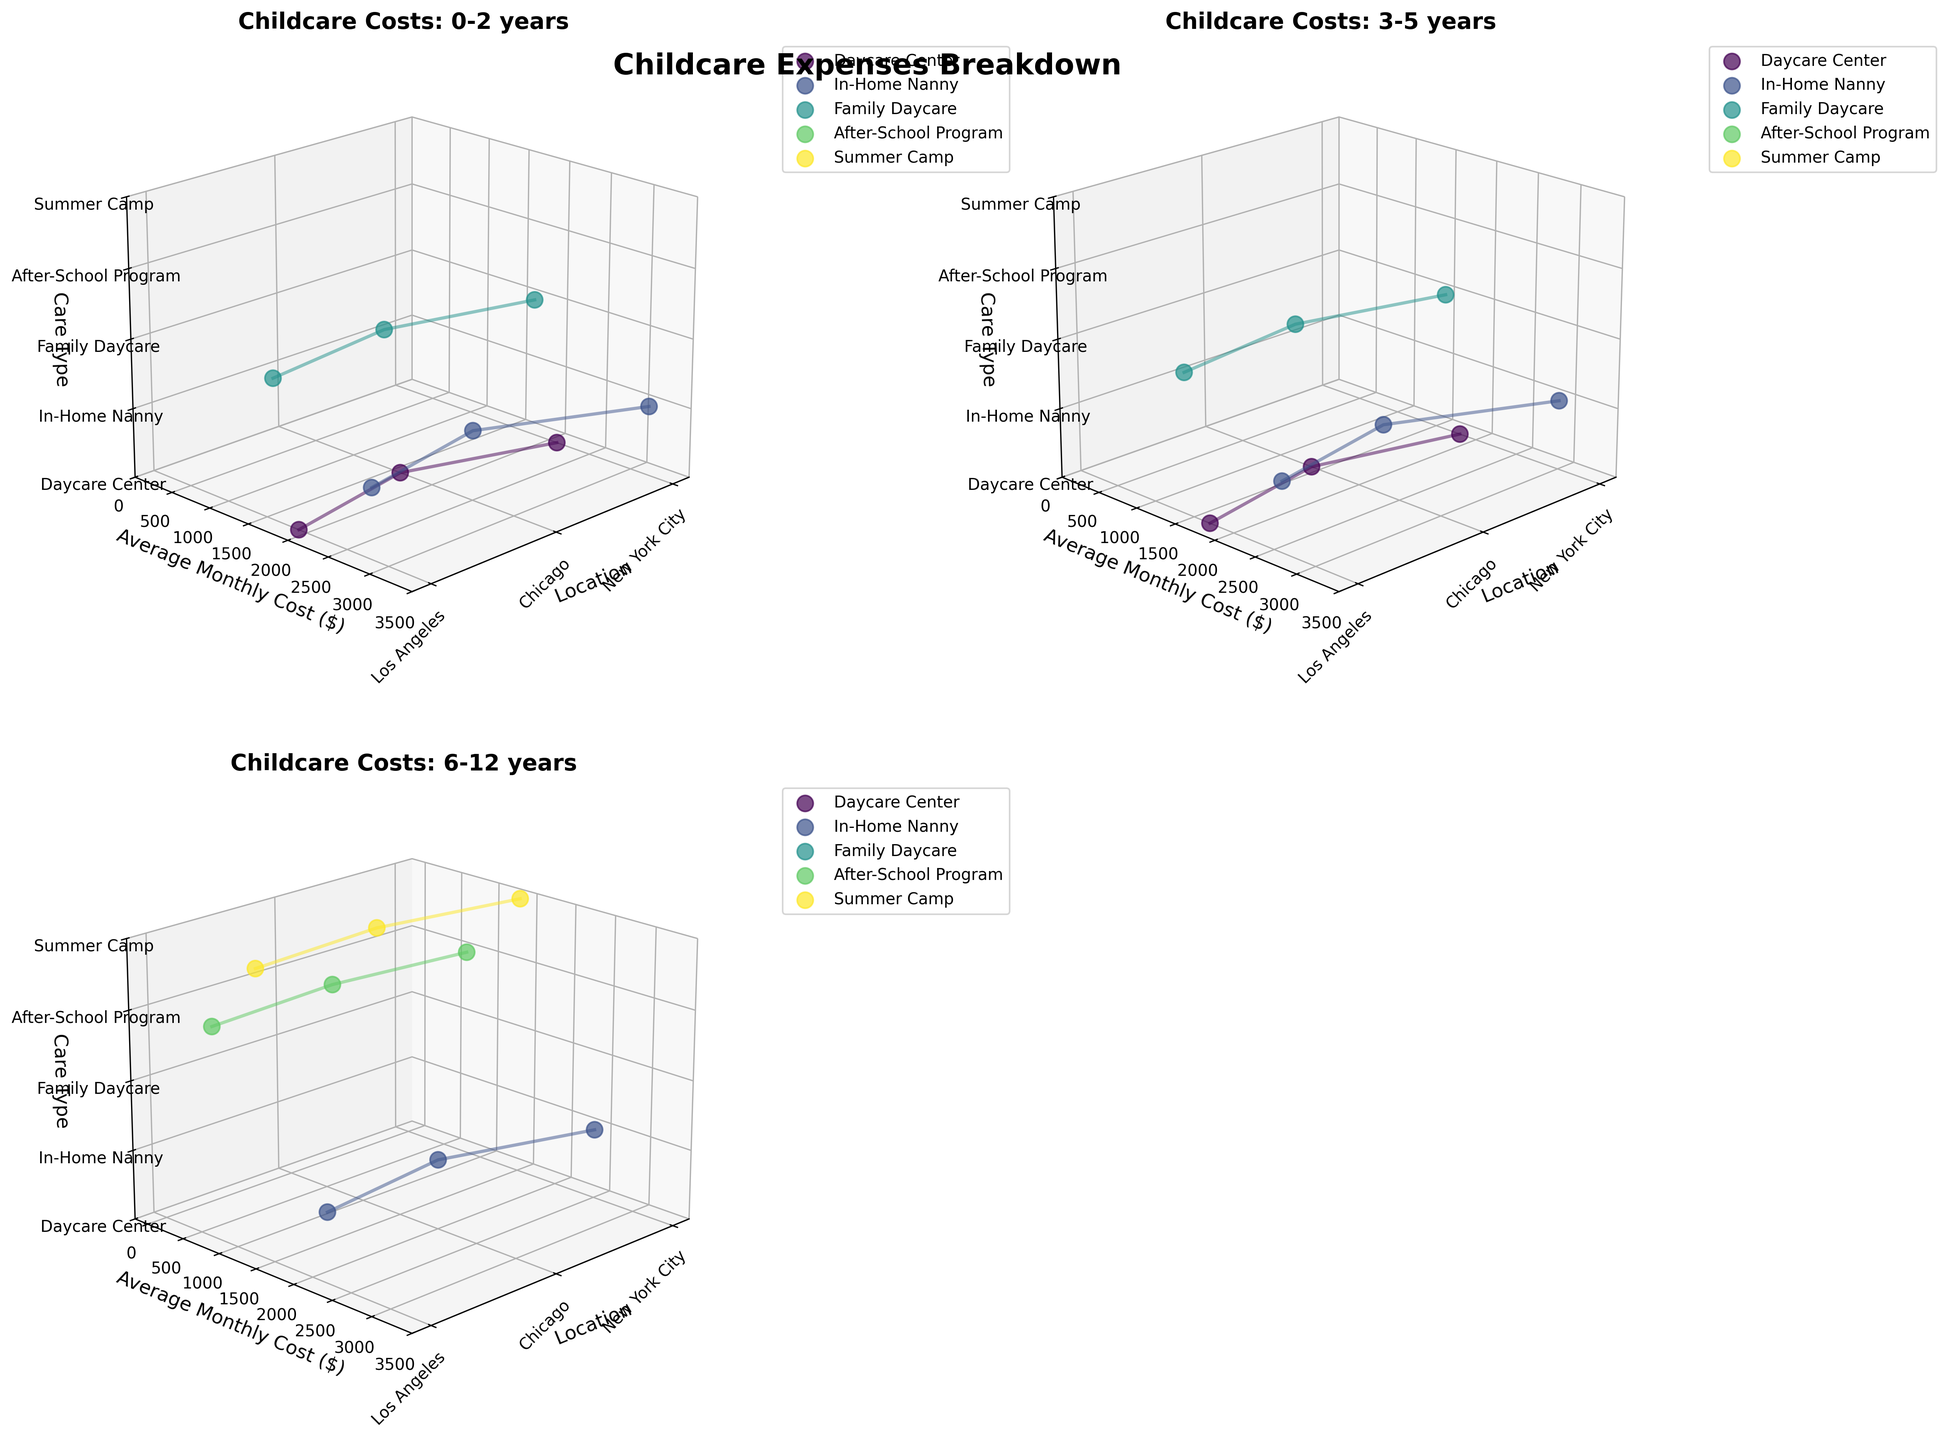What's the title of the figure? The title of the figure is indicated at the top and summarizes the overall content of the plots.
Answer: Childcare Expenses Breakdown Which age group has the plot in the top left corner? The top left plot is for the first age group listed in the subplot titles.
Answer: 0-2 years What is the x-axis label for each subplot? The x-axis label is displayed at the bottom of each subplot and describes the horizontal dimension of the plots.
Answer: Location How many unique childcare types are shown in each subplot? From the distinct colors/markers in the legend for each subplot, you can count the number of different care types displayed.
Answer: 3 for 0-5 years, 3 for 6-12 years Which geographic location has the highest average monthly cost for In-Home Nanny care for children aged 3-5 years? By examining the 3-5 years subplot, find the data points corresponding to In-Home Nanny care and compare their y-values across geographic locations.
Answer: New York City In the 6-12 years group, which care type has the lowest average monthly cost in Chicago? Look at the 6-12 years subplot and compare the y-values of the data points for Chicago across all care types.
Answer: After-School Program What is the average monthly cost for Daycare Center care for the 0-2 years age group in Los Angeles? Refer to the specific data point in the 0-2 years subplot highlighted by the Daycare Center marker in Los Angeles.
Answer: $1900 Is the cost of Family Daycare for 0-2 years old in Chicago higher or lower than in Los Angeles? Compare the y-values of Family Daycare in the 0-2 years subplot for Chicago and Los Angeles.
Answer: Lower Which age group has the highest variation in the average monthly cost for Daycare Center care across all locations? Examine the range of y-values for Daycare Center care across all locations in the corresponding subplots and identify the age group with the widest range.
Answer: 0-2 years What is the range of average monthly costs for In-Home Nanny care in Los Angeles for the 6-12 years age group? Check the In-Home Nanny data points in Los Angeles within the 6-12 years subplot to find the minimum and maximum y-values.
Answer: $2200 